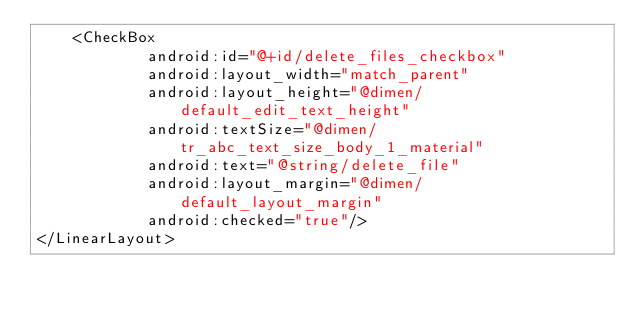Convert code to text. <code><loc_0><loc_0><loc_500><loc_500><_XML_>    <CheckBox
            android:id="@+id/delete_files_checkbox"
            android:layout_width="match_parent"
            android:layout_height="@dimen/default_edit_text_height"
            android:textSize="@dimen/tr_abc_text_size_body_1_material"
            android:text="@string/delete_file"
            android:layout_margin="@dimen/default_layout_margin"
            android:checked="true"/>
</LinearLayout></code> 